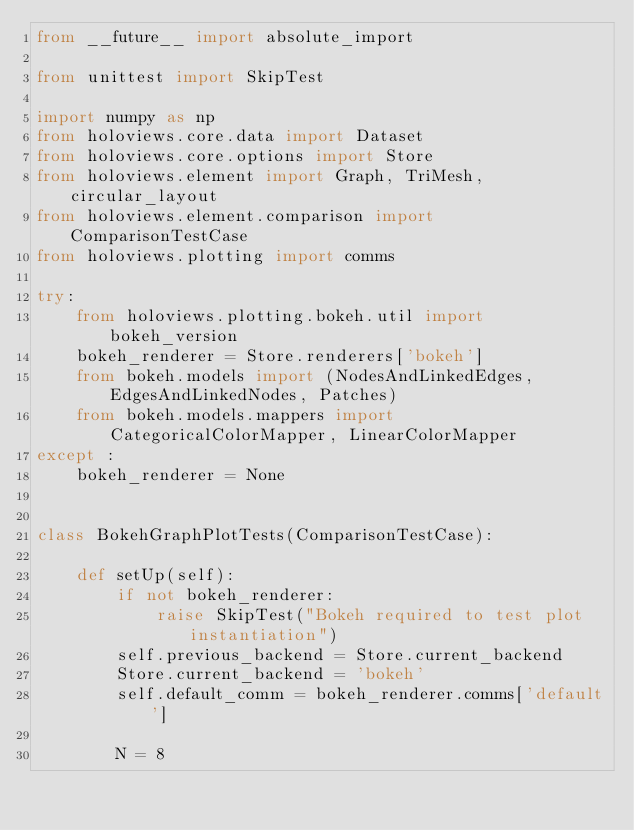<code> <loc_0><loc_0><loc_500><loc_500><_Python_>from __future__ import absolute_import

from unittest import SkipTest

import numpy as np
from holoviews.core.data import Dataset
from holoviews.core.options import Store
from holoviews.element import Graph, TriMesh, circular_layout
from holoviews.element.comparison import ComparisonTestCase
from holoviews.plotting import comms

try:
    from holoviews.plotting.bokeh.util import bokeh_version
    bokeh_renderer = Store.renderers['bokeh']
    from bokeh.models import (NodesAndLinkedEdges, EdgesAndLinkedNodes, Patches)
    from bokeh.models.mappers import CategoricalColorMapper, LinearColorMapper
except :
    bokeh_renderer = None


class BokehGraphPlotTests(ComparisonTestCase):
    
    def setUp(self):
        if not bokeh_renderer:
            raise SkipTest("Bokeh required to test plot instantiation")
        self.previous_backend = Store.current_backend
        Store.current_backend = 'bokeh'
        self.default_comm = bokeh_renderer.comms['default']

        N = 8</code> 